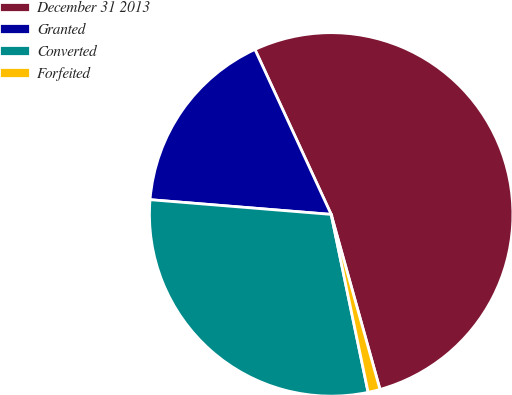<chart> <loc_0><loc_0><loc_500><loc_500><pie_chart><fcel>December 31 2013<fcel>Granted<fcel>Converted<fcel>Forfeited<nl><fcel>52.56%<fcel>16.82%<fcel>29.55%<fcel>1.07%<nl></chart> 